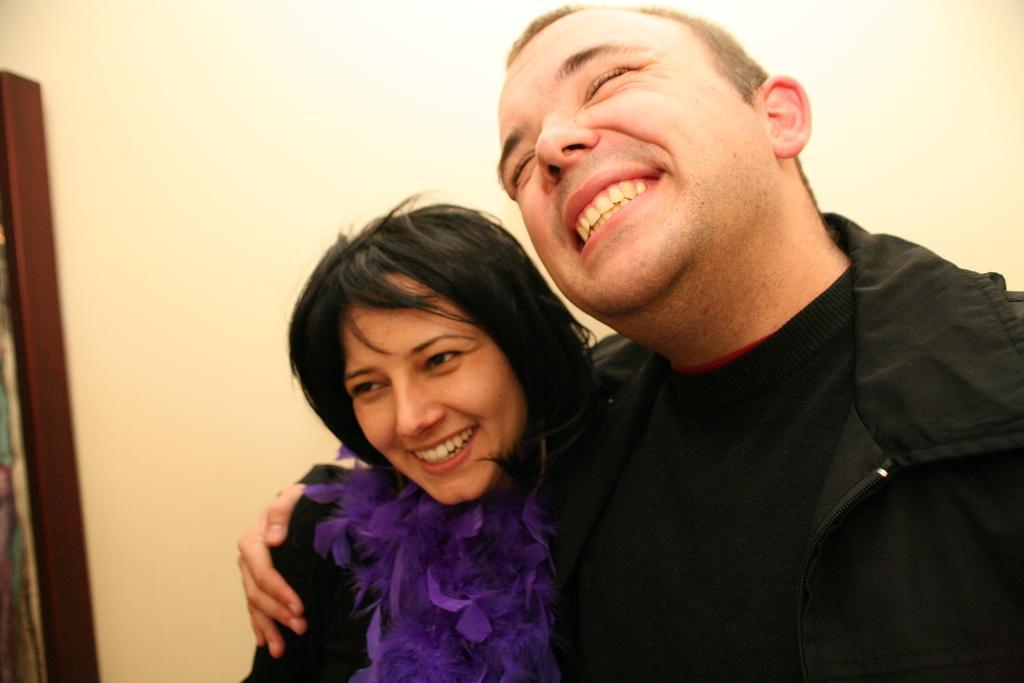Can you describe this image briefly? In this picture there is a person wearing black jacket is smiling and placed one of his hand on a woman beside him and there is an object in the left corner. 